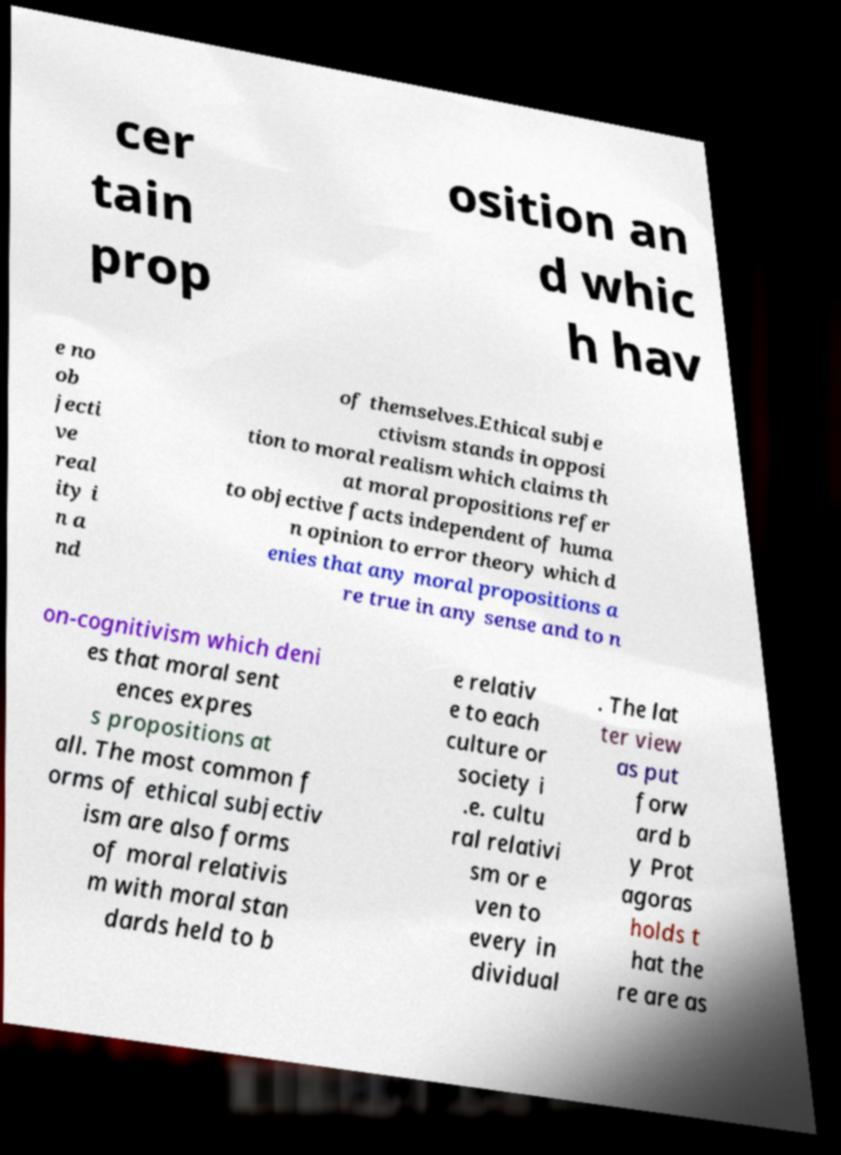Can you accurately transcribe the text from the provided image for me? cer tain prop osition an d whic h hav e no ob jecti ve real ity i n a nd of themselves.Ethical subje ctivism stands in opposi tion to moral realism which claims th at moral propositions refer to objective facts independent of huma n opinion to error theory which d enies that any moral propositions a re true in any sense and to n on-cognitivism which deni es that moral sent ences expres s propositions at all. The most common f orms of ethical subjectiv ism are also forms of moral relativis m with moral stan dards held to b e relativ e to each culture or society i .e. cultu ral relativi sm or e ven to every in dividual . The lat ter view as put forw ard b y Prot agoras holds t hat the re are as 